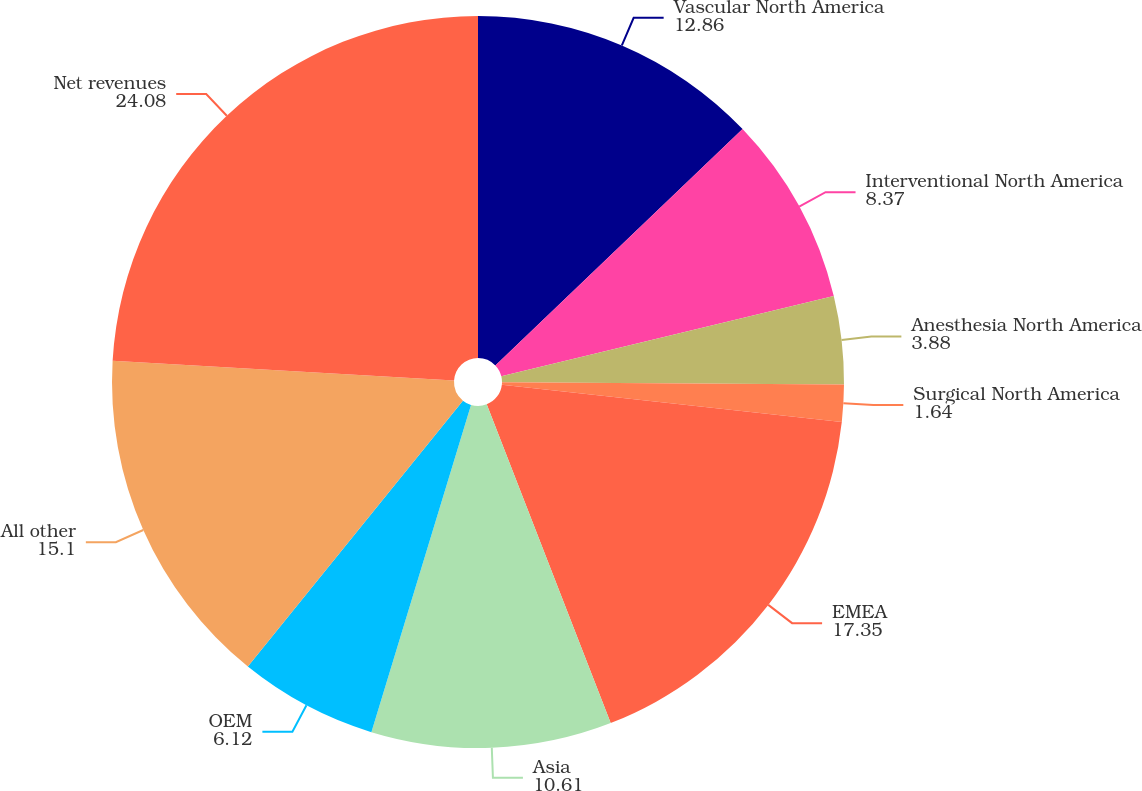<chart> <loc_0><loc_0><loc_500><loc_500><pie_chart><fcel>Vascular North America<fcel>Interventional North America<fcel>Anesthesia North America<fcel>Surgical North America<fcel>EMEA<fcel>Asia<fcel>OEM<fcel>All other<fcel>Net revenues<nl><fcel>12.86%<fcel>8.37%<fcel>3.88%<fcel>1.64%<fcel>17.35%<fcel>10.61%<fcel>6.12%<fcel>15.1%<fcel>24.08%<nl></chart> 